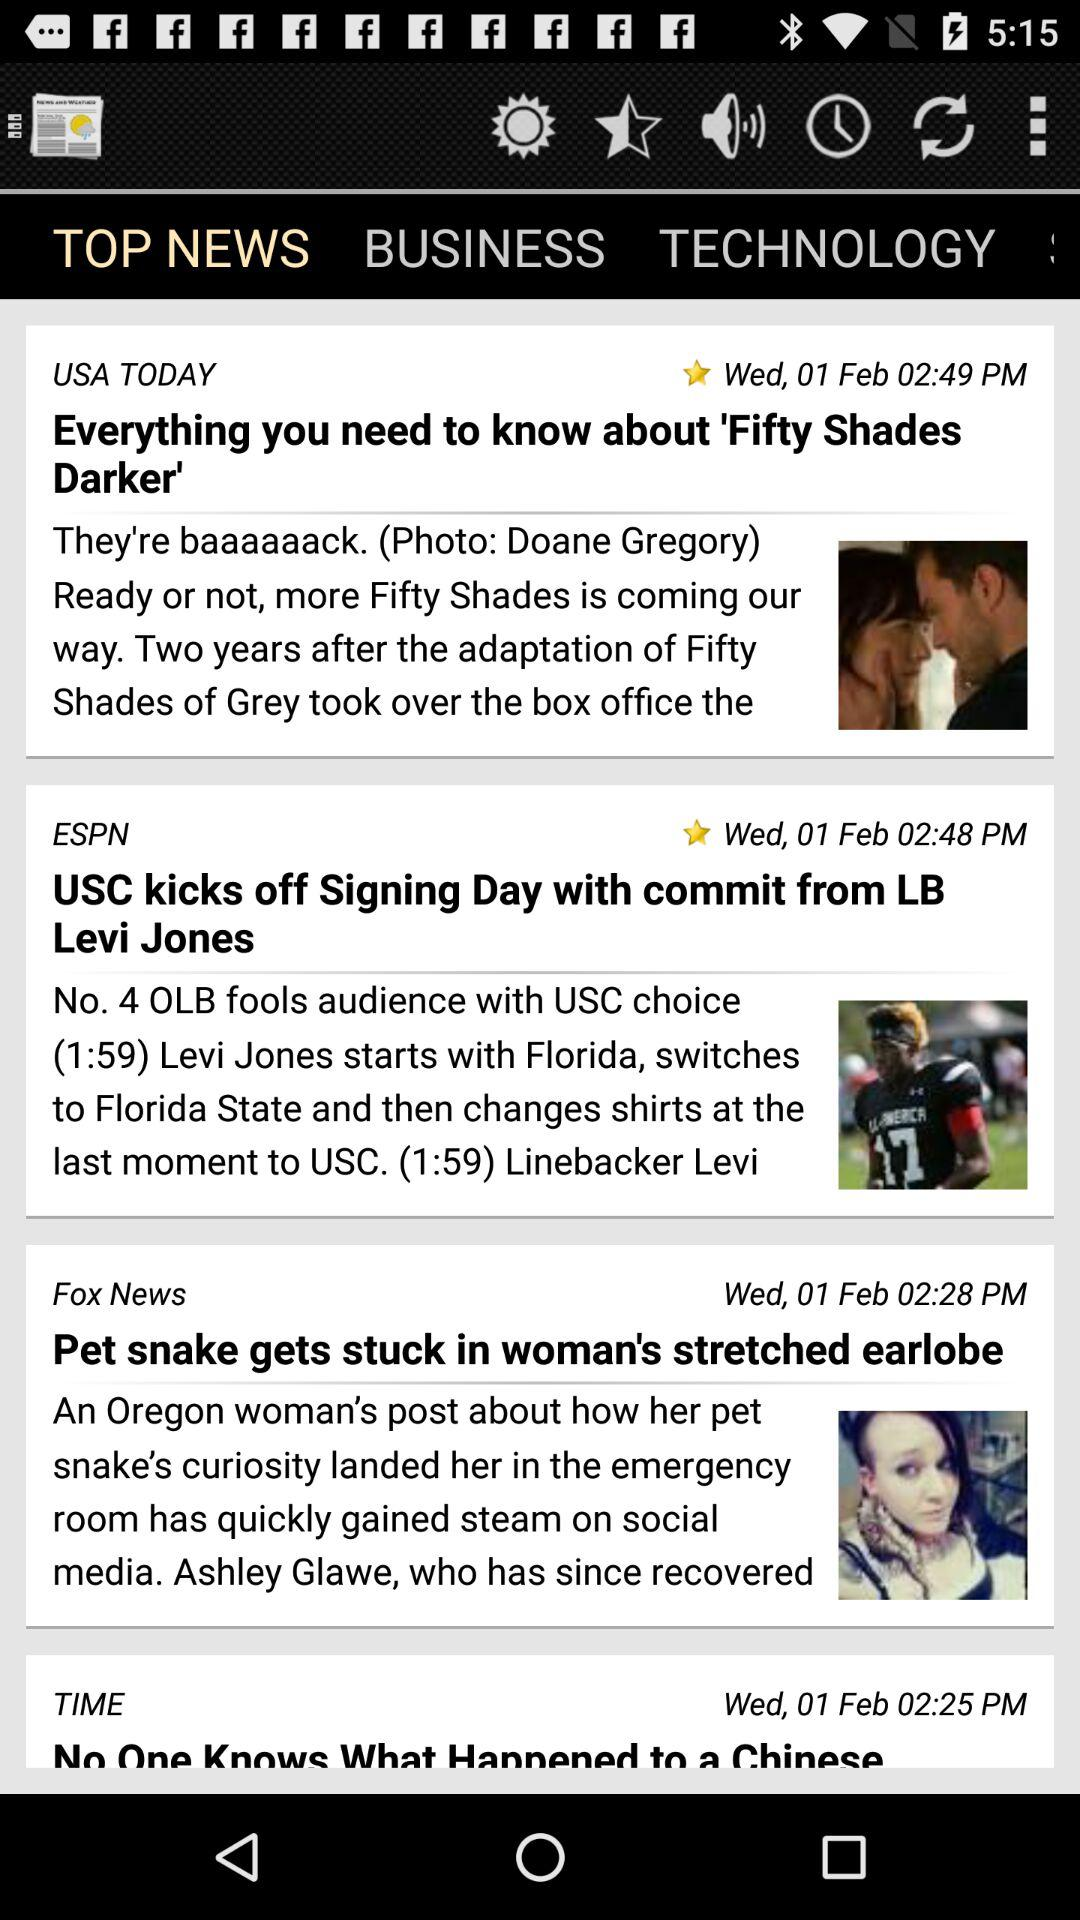Which tab is selected? The selected tab is "TOP NEWS". 